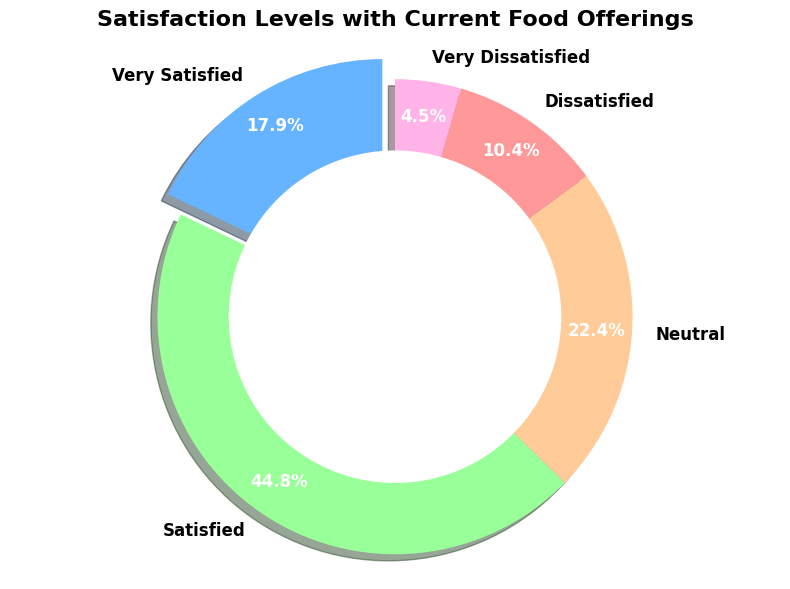What percentage of respondents are either very dissatisfied or dissatisfied with the current food offerings? Add the percentages of "Very Dissatisfied" (4.3%) and "Dissatisfied" (10.0%). Therefore, 4.3% + 10.0% = 14.3%
Answer: 14.3% Which satisfaction level has the highest percentage of respondents? The "Satisfied" category has the highest percentage at 42.9% as indicated by the chart's largest section.
Answer: Satisfied What is the combined percentage of respondents who are neutral or very satisfied with the current food offerings? Add the percentages of "Neutral" (21.4%) and "Very Satisfied" (17.1%). Therefore, 21.4% + 17.1% = 38.5%
Answer: 38.5% Is the number of respondents who are neutral greater than the number of those who are dissatisfied? There are 150 respondents who are neutral and 70 who are dissatisfied. Since 150 > 70, the number of neutral respondents is greater.
Answer: Yes What is the most common satisfaction level, and what color is its section in the pie chart? The most common satisfaction level is "Satisfied." Its section in the pie chart is colored green.
Answer: Satisfied, green Compare the proportion of respondents who are very satisfied or satisfied with those who are very dissatisfied. Which is greater? Add the percentages of "Very Satisfied" (17.1%) and "Satisfied" (42.9%). Subtract the percentage of "Very Dissatisfied" (4.3%). Therefore, 60.0% - 4.3% = 55.7%. Since 55.7% > 4.3%, the combined proportion of very satisfied and satisfied is greater.
Answer: Very satisfied or satisfied What is the difference in the percentage of respondents between the "Satisfied" and "Very Satisfied" categories? Subtract the percentage of "Very Satisfied" (17.1%) from "Satisfied" (42.9%). Therefore, 42.9% - 17.1% = 25.8%
Answer: 25.8% Which slice of the pie chart is the smallest, and what percentage does it represent? The smallest slice is "Very Dissatisfied," representing 4.3% as indicated by the smallest section.
Answer: Very Dissatisfied, 4.3% What portion of respondents are not dissatisfied with the food offerings? Add the percentages of "Very Satisfied" (17.1%), "Satisfied" (42.9%), and "Neutral" (21.4%). Therefore, 17.1% + 42.9% + 21.4% = 81.4%
Answer: 81.4% 